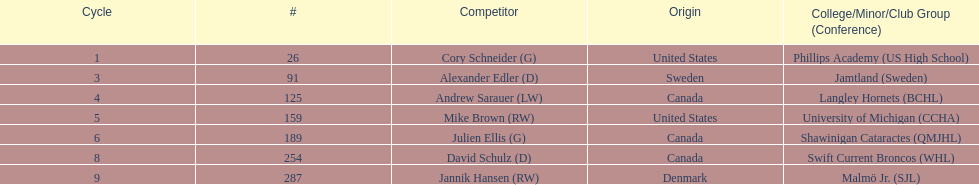List each player drafted from canada. Andrew Sarauer (LW), Julien Ellis (G), David Schulz (D). 